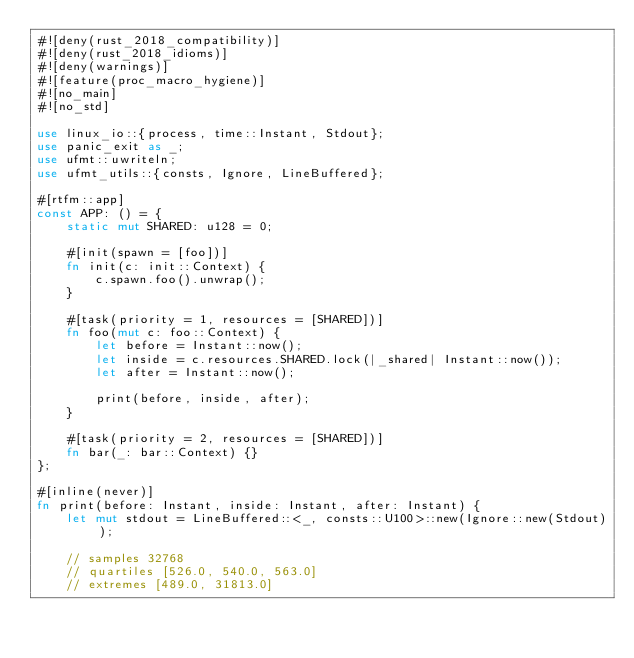<code> <loc_0><loc_0><loc_500><loc_500><_Rust_>#![deny(rust_2018_compatibility)]
#![deny(rust_2018_idioms)]
#![deny(warnings)]
#![feature(proc_macro_hygiene)]
#![no_main]
#![no_std]

use linux_io::{process, time::Instant, Stdout};
use panic_exit as _;
use ufmt::uwriteln;
use ufmt_utils::{consts, Ignore, LineBuffered};

#[rtfm::app]
const APP: () = {
    static mut SHARED: u128 = 0;

    #[init(spawn = [foo])]
    fn init(c: init::Context) {
        c.spawn.foo().unwrap();
    }

    #[task(priority = 1, resources = [SHARED])]
    fn foo(mut c: foo::Context) {
        let before = Instant::now();
        let inside = c.resources.SHARED.lock(|_shared| Instant::now());
        let after = Instant::now();

        print(before, inside, after);
    }

    #[task(priority = 2, resources = [SHARED])]
    fn bar(_: bar::Context) {}
};

#[inline(never)]
fn print(before: Instant, inside: Instant, after: Instant) {
    let mut stdout = LineBuffered::<_, consts::U100>::new(Ignore::new(Stdout));

    // samples 32768
    // quartiles [526.0, 540.0, 563.0]
    // extremes [489.0, 31813.0]</code> 